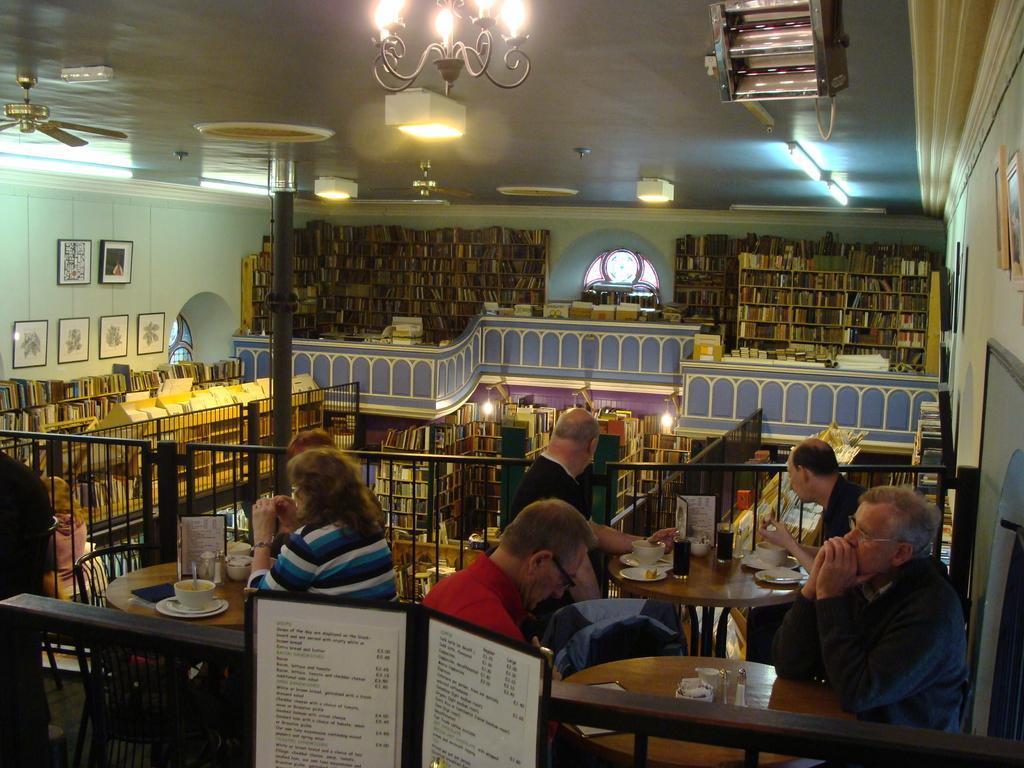Could you give a brief overview of what you see in this image? In this image on the right there is a table, cup, plate and four men sitting on the chairs. On the left there is a woman, table and chairs. In the back ground there is a library, books, light, fan ,photo frame , window and wall. 